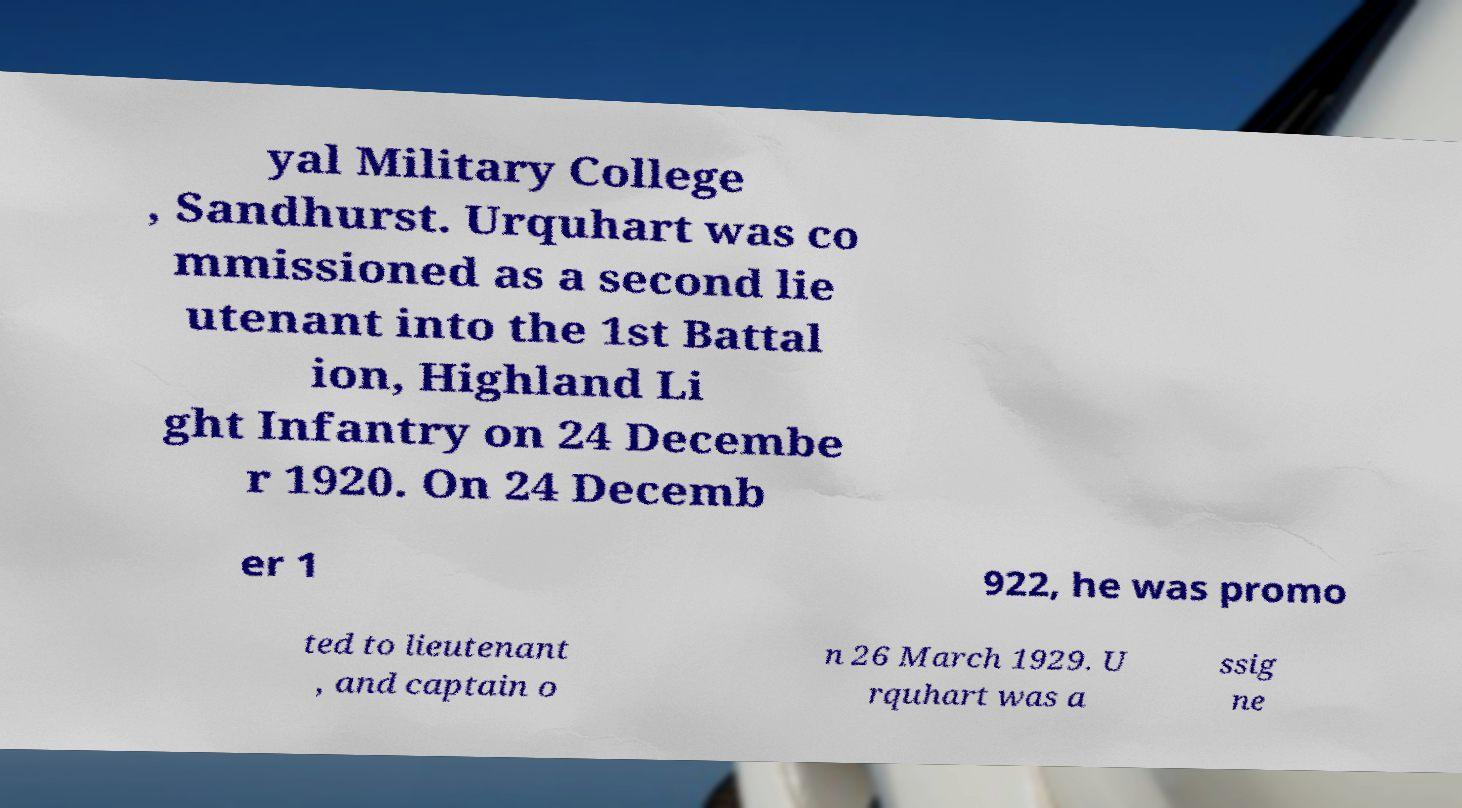Please read and relay the text visible in this image. What does it say? yal Military College , Sandhurst. Urquhart was co mmissioned as a second lie utenant into the 1st Battal ion, Highland Li ght Infantry on 24 Decembe r 1920. On 24 Decemb er 1 922, he was promo ted to lieutenant , and captain o n 26 March 1929. U rquhart was a ssig ne 